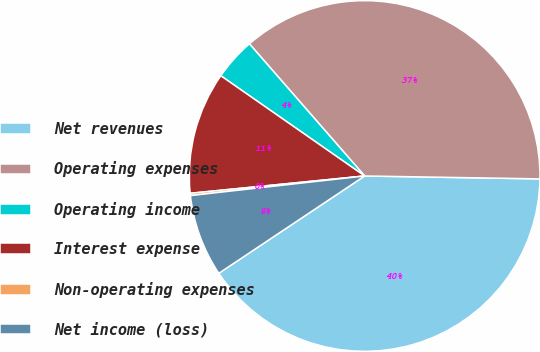Convert chart. <chart><loc_0><loc_0><loc_500><loc_500><pie_chart><fcel>Net revenues<fcel>Operating expenses<fcel>Operating income<fcel>Interest expense<fcel>Non-operating expenses<fcel>Net income (loss)<nl><fcel>40.37%<fcel>36.68%<fcel>3.9%<fcel>11.26%<fcel>0.21%<fcel>7.58%<nl></chart> 